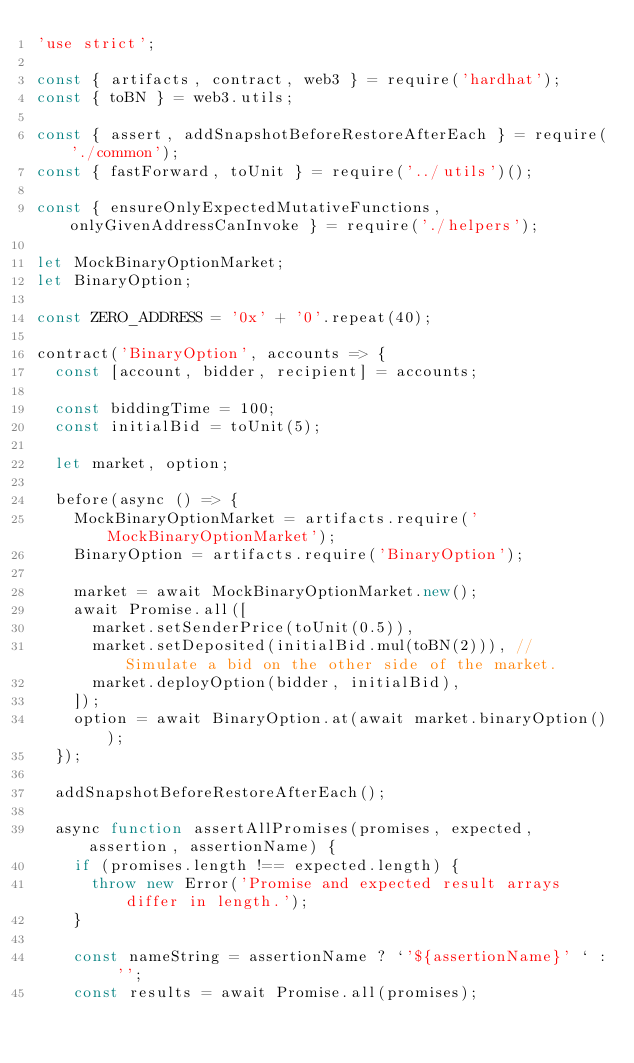<code> <loc_0><loc_0><loc_500><loc_500><_JavaScript_>'use strict';

const { artifacts, contract, web3 } = require('hardhat');
const { toBN } = web3.utils;

const { assert, addSnapshotBeforeRestoreAfterEach } = require('./common');
const { fastForward, toUnit } = require('../utils')();

const { ensureOnlyExpectedMutativeFunctions, onlyGivenAddressCanInvoke } = require('./helpers');

let MockBinaryOptionMarket;
let BinaryOption;

const ZERO_ADDRESS = '0x' + '0'.repeat(40);

contract('BinaryOption', accounts => {
	const [account, bidder, recipient] = accounts;

	const biddingTime = 100;
	const initialBid = toUnit(5);

	let market, option;

	before(async () => {
		MockBinaryOptionMarket = artifacts.require('MockBinaryOptionMarket');
		BinaryOption = artifacts.require('BinaryOption');

		market = await MockBinaryOptionMarket.new();
		await Promise.all([
			market.setSenderPrice(toUnit(0.5)),
			market.setDeposited(initialBid.mul(toBN(2))), // Simulate a bid on the other side of the market.
			market.deployOption(bidder, initialBid),
		]);
		option = await BinaryOption.at(await market.binaryOption());
	});

	addSnapshotBeforeRestoreAfterEach();

	async function assertAllPromises(promises, expected, assertion, assertionName) {
		if (promises.length !== expected.length) {
			throw new Error('Promise and expected result arrays differ in length.');
		}

		const nameString = assertionName ? `'${assertionName}' ` : '';
		const results = await Promise.all(promises);</code> 